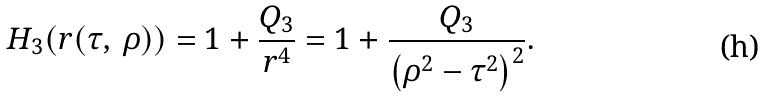<formula> <loc_0><loc_0><loc_500><loc_500>H _ { 3 } ( r ( \tau , \, \rho ) ) = 1 + \frac { Q _ { 3 } } { r ^ { 4 } } = 1 + \frac { Q _ { 3 } } { \left ( \rho ^ { 2 } - \tau ^ { 2 } \right ) ^ { 2 } } .</formula> 